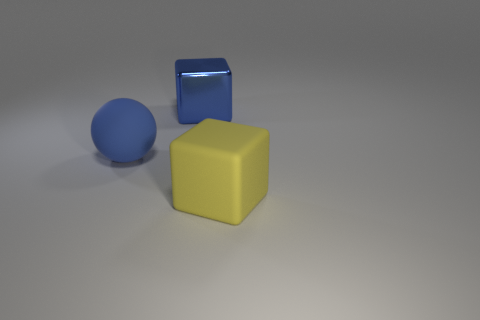Add 3 small purple rubber blocks. How many objects exist? 6 Subtract all balls. How many objects are left? 2 Add 1 small red matte balls. How many small red matte balls exist? 1 Subtract 0 brown spheres. How many objects are left? 3 Subtract all blue metal blocks. Subtract all blue things. How many objects are left? 0 Add 3 big rubber spheres. How many big rubber spheres are left? 4 